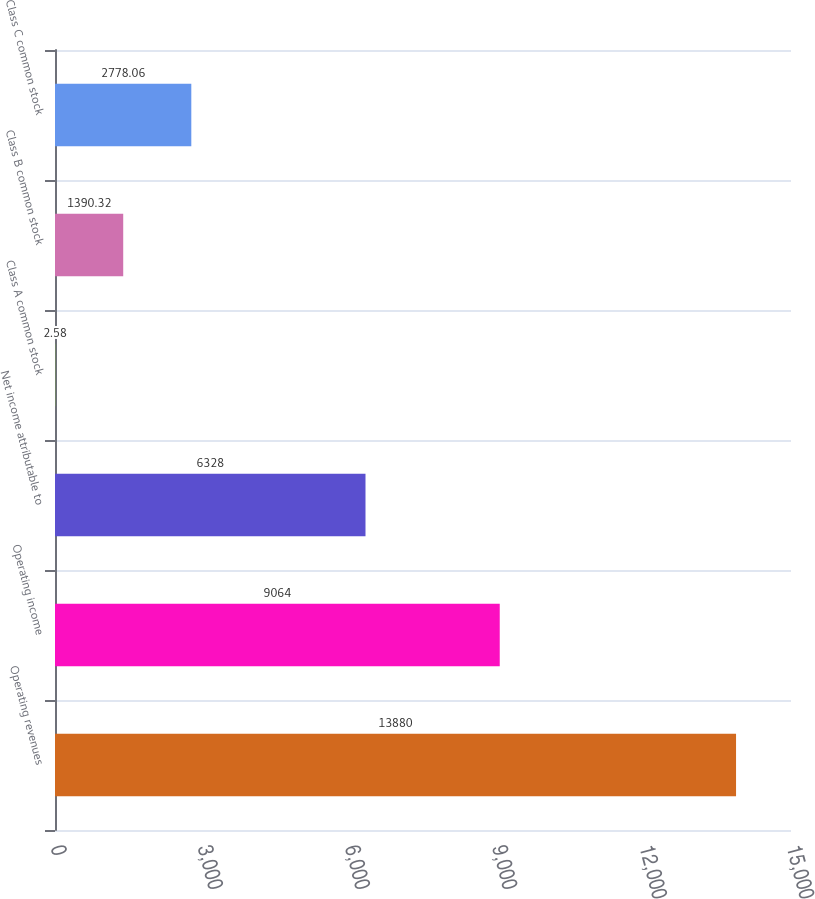Convert chart to OTSL. <chart><loc_0><loc_0><loc_500><loc_500><bar_chart><fcel>Operating revenues<fcel>Operating income<fcel>Net income attributable to<fcel>Class A common stock<fcel>Class B common stock<fcel>Class C common stock<nl><fcel>13880<fcel>9064<fcel>6328<fcel>2.58<fcel>1390.32<fcel>2778.06<nl></chart> 